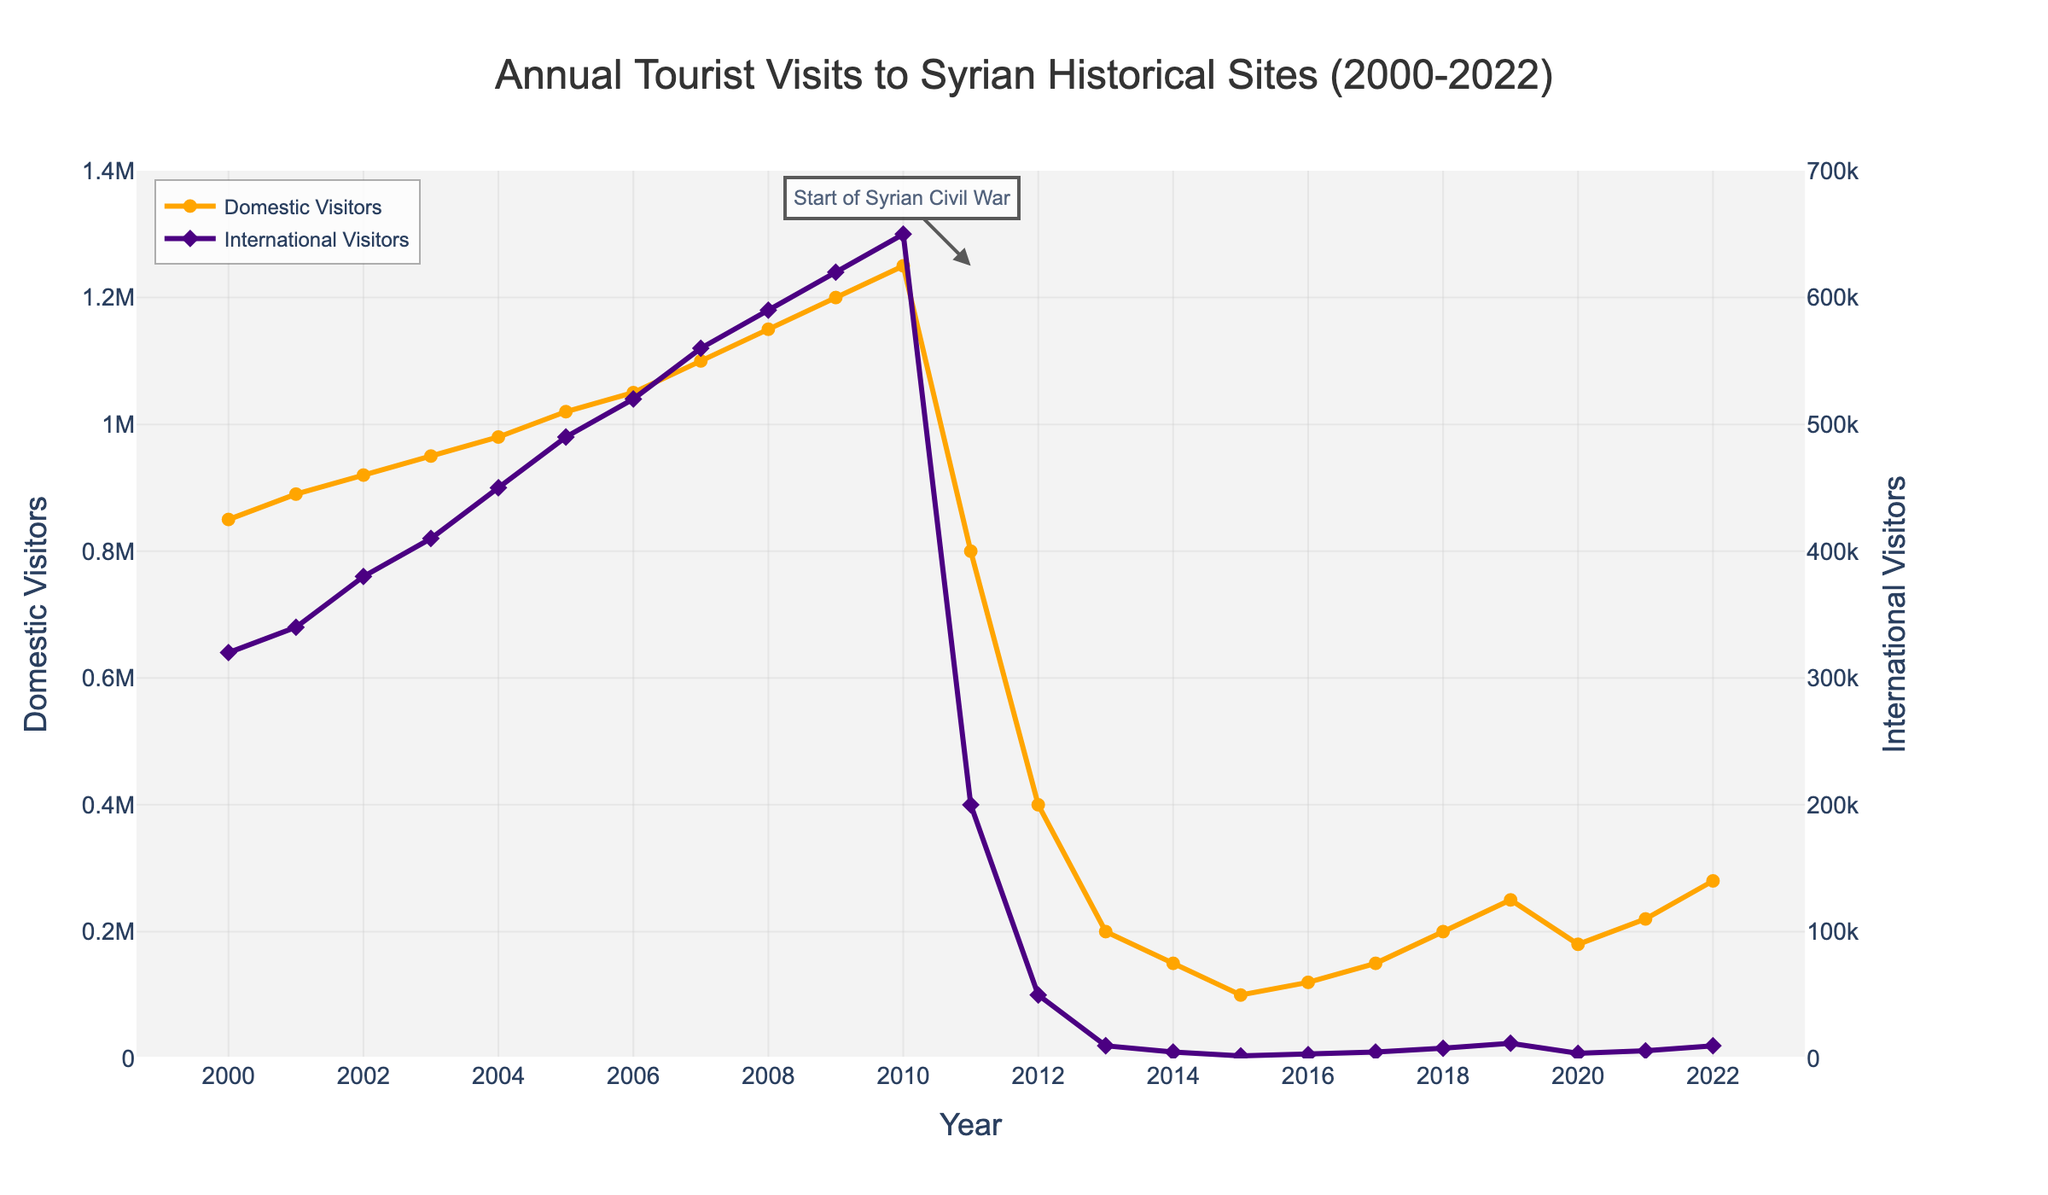Which year had the highest number of domestic visitors? To find the year with the highest number of domestic visitors, look for the peak point on the "Domestic Visitors" line (orange) in the chart. This peak occurs in the year 2010.
Answer: 2010 What was the approximate difference in the number of international visitors between 2010 and 2013? Locate the points for the years 2010 and 2013 on the "International Visitors" line (purple). In 2010, there were approximately 650,000 visitors, and in 2013, there were about 10,000. The difference is 650,000 - 10,000 = 640,000.
Answer: 640,000 How did the number of domestic visitors change from 2011 to 2012? Identify the values for domestic visitors for 2011 and 2012 on the orange line. In 2011, there were 800,000 visitors, and in 2012, there were 400,000. The change is 800,000 - 400,000 = 400,000.
Answer: Decreased by 400,000 Which year marked the lowest point for international visitors? The lowest point on the "International Visitors" line (purple) represents the year with the fewest visitors. This lowest point is in the year 2015 with approximately 2,000 visitors.
Answer: 2015 Compare the number of international visitors in 2005 and 2022. Which year had more international visitors? Identify the points for 2005 and 2022 on the purple line. In 2005, there were about 490,000 visitors, and in 2022, there were roughly 10,000 visitors. Therefore, 2005 had more international visitors.
Answer: 2005 What is the average number of domestic visitors from 2000 to 2010? Sum the values of domestic visitors from 2000 to 2010 and then divide by the number of years. Sum: 850,000 + 890,000 + 920,000 + 950,000 + 980,000 + 1,020,000 + 1,050,000 + 1,100,000 + 1,150,000 + 1,200,000 + 1,250,000 = 11,360,000. Number of years: 11. Average = 11,360,000 / 11 ≈ 1,032,727.
Answer: 1,032,727 Which type of visitor saw a steeper decline between 2010 and 2014? Evaluate the slopes of the decline for both domestic (orange) and international (purple) visitors between 2010 and 2014. Domestic visitors dropped from 1,250,000 to 150,000 (a decline of 1,100,000), while international visitors decreased from 650,000 to 5,000 (a decline of 645,000). The steeper decline is in domestic visitors.
Answer: Domestic visitors In which year did the number of domestic visitors first surpass 1 million? Locate the point where the "Domestic Visitors" line (orange) first crosses the 1 million mark. This occurs in the year 2005.
Answer: 2005 By how much did the number of domestic visitors increase from 2003 to 2008? Determine the number of domestic visitors in 2003 and 2008 from the orange line. In 2003, there were 950,000 visitors, and in 2008, there were 1,150,000 visitors. The increase is 1,150,000 - 950,000 = 200,000.
Answer: 200,000 